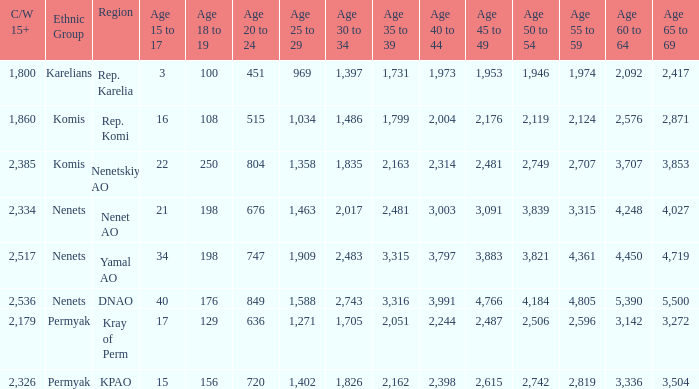What is the total 60 to 64 when the Oblast\Age is Nenets in Yamal AO, and the 45 to 49 is bigger than 3,883? None. 